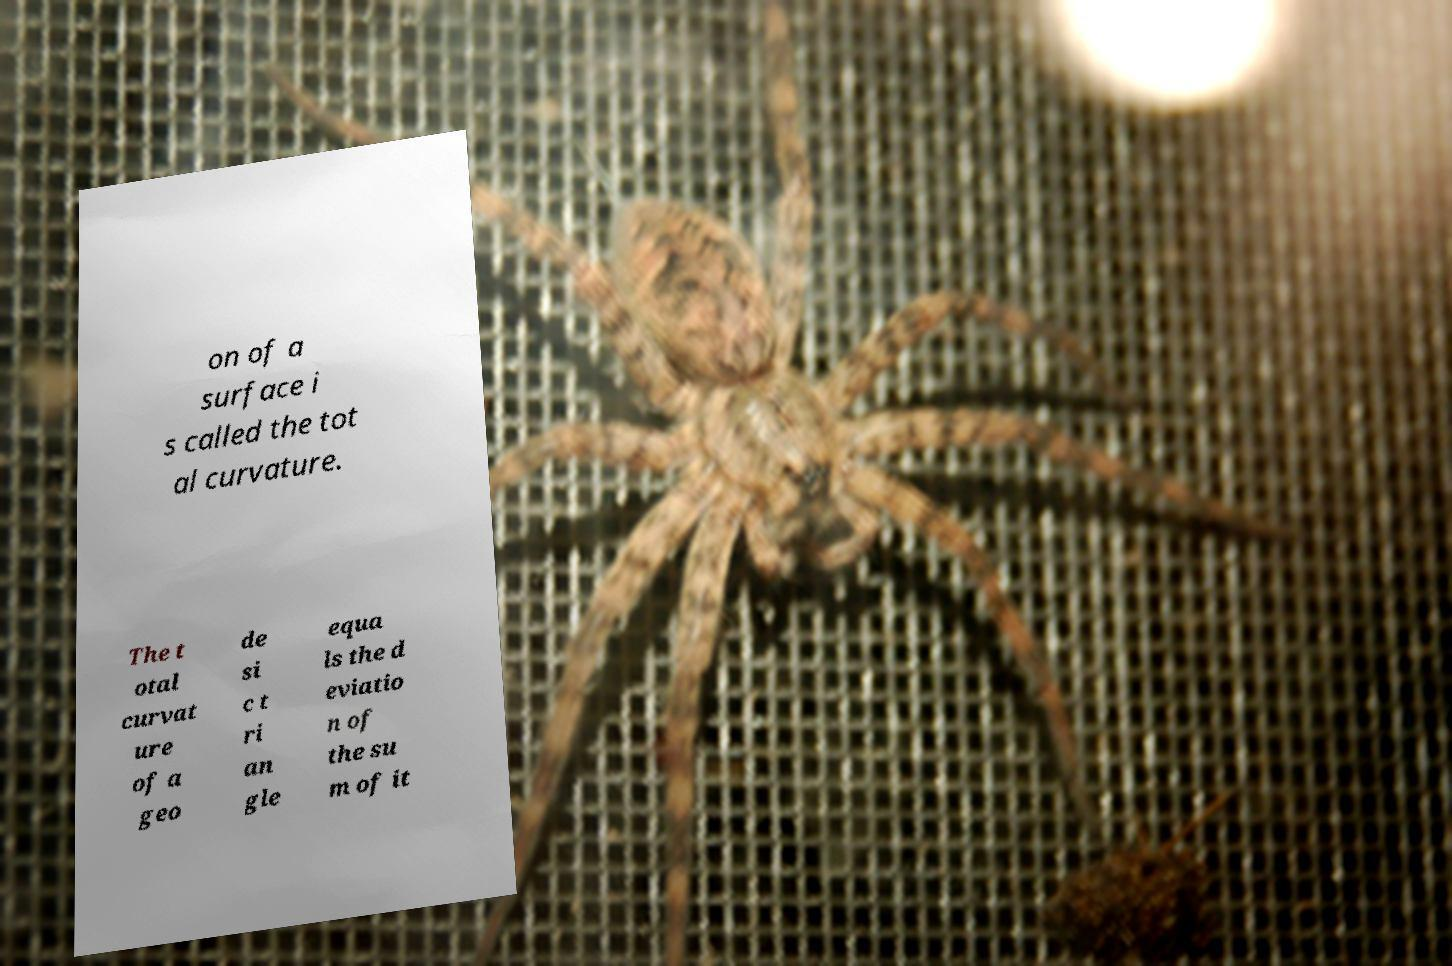Can you accurately transcribe the text from the provided image for me? on of a surface i s called the tot al curvature. The t otal curvat ure of a geo de si c t ri an gle equa ls the d eviatio n of the su m of it 